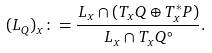<formula> <loc_0><loc_0><loc_500><loc_500>( L _ { Q } ) _ { x } \colon = \frac { L _ { x } \cap ( T _ { x } Q \oplus T ^ { * } _ { x } P ) } { L _ { x } \cap T _ { x } Q ^ { \circ } } .</formula> 